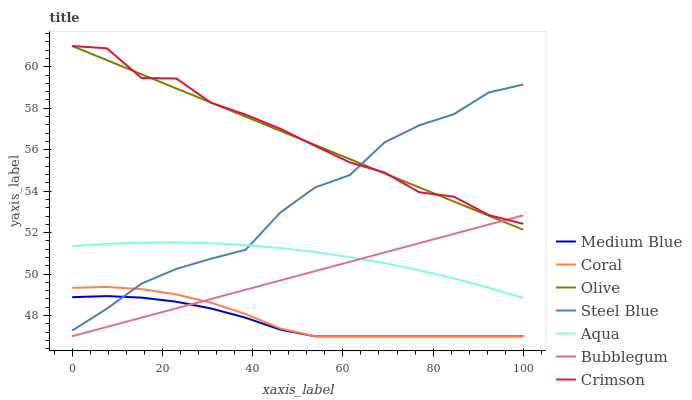Does Medium Blue have the minimum area under the curve?
Answer yes or no. Yes. Does Crimson have the maximum area under the curve?
Answer yes or no. Yes. Does Coral have the minimum area under the curve?
Answer yes or no. No. Does Coral have the maximum area under the curve?
Answer yes or no. No. Is Olive the smoothest?
Answer yes or no. Yes. Is Crimson the roughest?
Answer yes or no. Yes. Is Coral the smoothest?
Answer yes or no. No. Is Coral the roughest?
Answer yes or no. No. Does Medium Blue have the lowest value?
Answer yes or no. Yes. Does Aqua have the lowest value?
Answer yes or no. No. Does Olive have the highest value?
Answer yes or no. Yes. Does Coral have the highest value?
Answer yes or no. No. Is Medium Blue less than Aqua?
Answer yes or no. Yes. Is Crimson greater than Coral?
Answer yes or no. Yes. Does Aqua intersect Steel Blue?
Answer yes or no. Yes. Is Aqua less than Steel Blue?
Answer yes or no. No. Is Aqua greater than Steel Blue?
Answer yes or no. No. Does Medium Blue intersect Aqua?
Answer yes or no. No. 